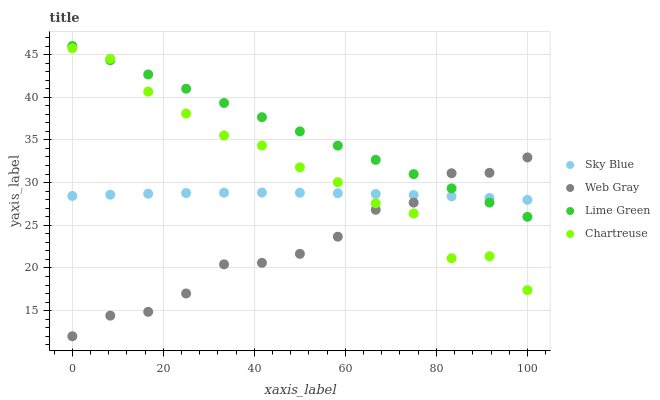Does Web Gray have the minimum area under the curve?
Answer yes or no. Yes. Does Lime Green have the maximum area under the curve?
Answer yes or no. Yes. Does Chartreuse have the minimum area under the curve?
Answer yes or no. No. Does Chartreuse have the maximum area under the curve?
Answer yes or no. No. Is Lime Green the smoothest?
Answer yes or no. Yes. Is Chartreuse the roughest?
Answer yes or no. Yes. Is Web Gray the smoothest?
Answer yes or no. No. Is Web Gray the roughest?
Answer yes or no. No. Does Web Gray have the lowest value?
Answer yes or no. Yes. Does Chartreuse have the lowest value?
Answer yes or no. No. Does Lime Green have the highest value?
Answer yes or no. Yes. Does Chartreuse have the highest value?
Answer yes or no. No. Does Chartreuse intersect Sky Blue?
Answer yes or no. Yes. Is Chartreuse less than Sky Blue?
Answer yes or no. No. Is Chartreuse greater than Sky Blue?
Answer yes or no. No. 